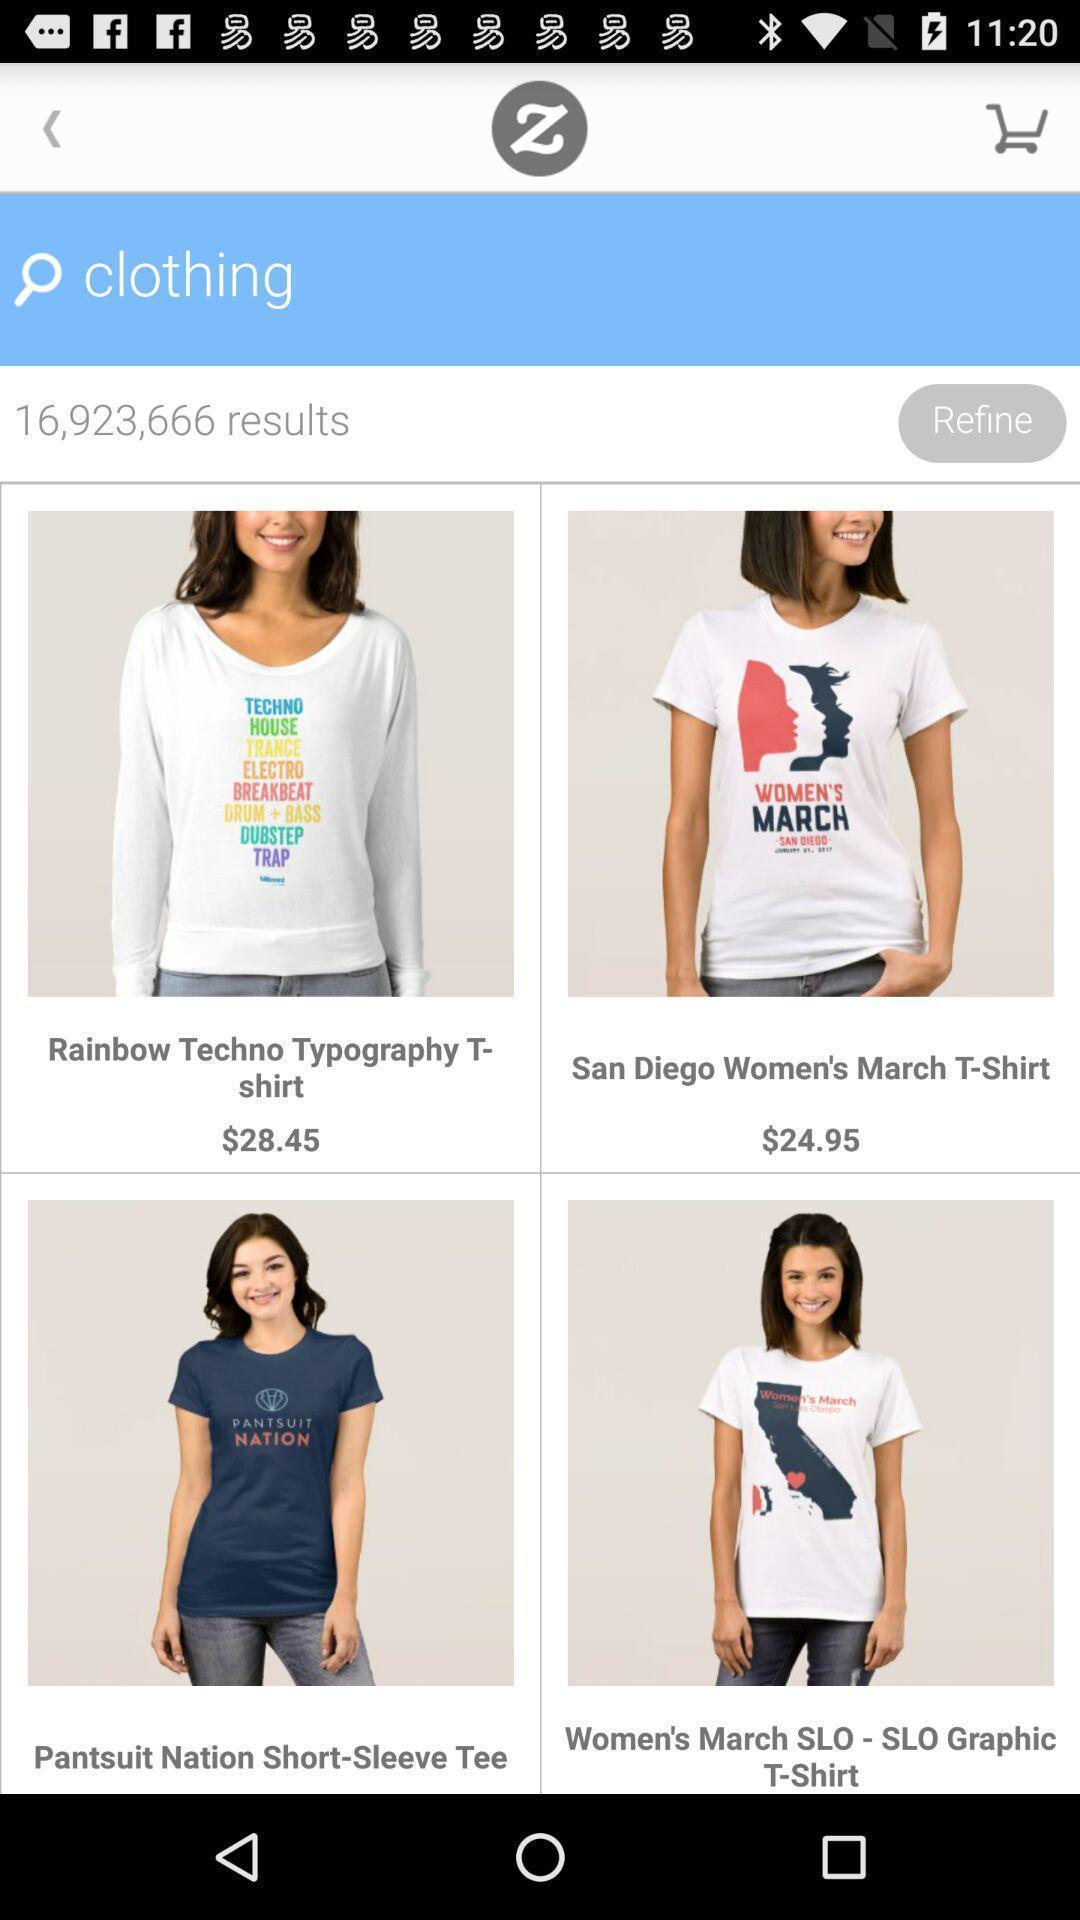Provide a textual representation of this image. Page showing the product latest in shopping app. 